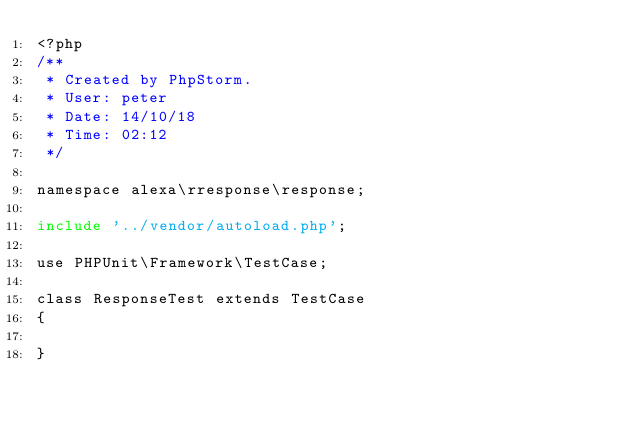Convert code to text. <code><loc_0><loc_0><loc_500><loc_500><_PHP_><?php
/**
 * Created by PhpStorm.
 * User: peter
 * Date: 14/10/18
 * Time: 02:12
 */

namespace alexa\rresponse\response;

include '../vendor/autoload.php';

use PHPUnit\Framework\TestCase;

class ResponseTest extends TestCase
{

}
</code> 